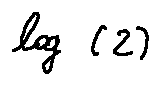<formula> <loc_0><loc_0><loc_500><loc_500>\log ( 2 )</formula> 